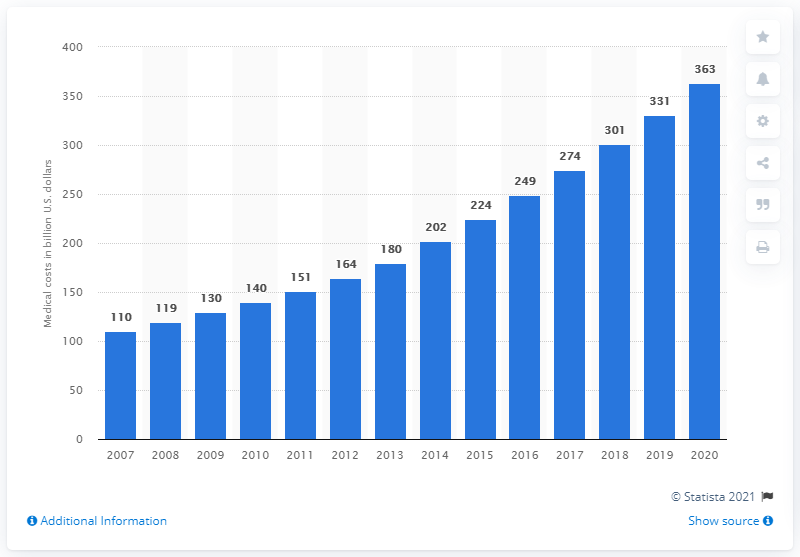Highlight a few significant elements in this photo. In 2020, the estimated total medical costs for adults with type 2 diabetes in the United States were approximately $363 billion. 